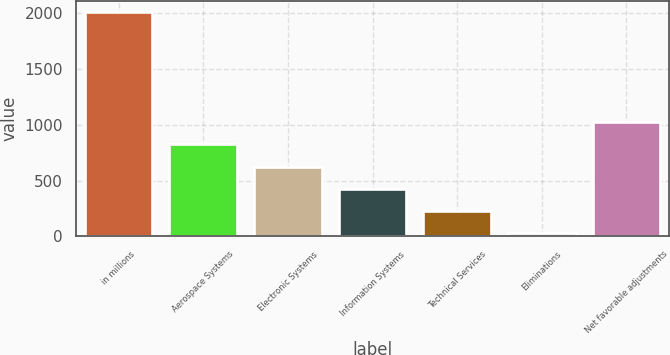<chart> <loc_0><loc_0><loc_500><loc_500><bar_chart><fcel>in millions<fcel>Aerospace Systems<fcel>Electronic Systems<fcel>Information Systems<fcel>Technical Services<fcel>Eliminations<fcel>Net favorable adjustments<nl><fcel>2014<fcel>824.8<fcel>626.6<fcel>428.4<fcel>230.2<fcel>32<fcel>1023<nl></chart> 